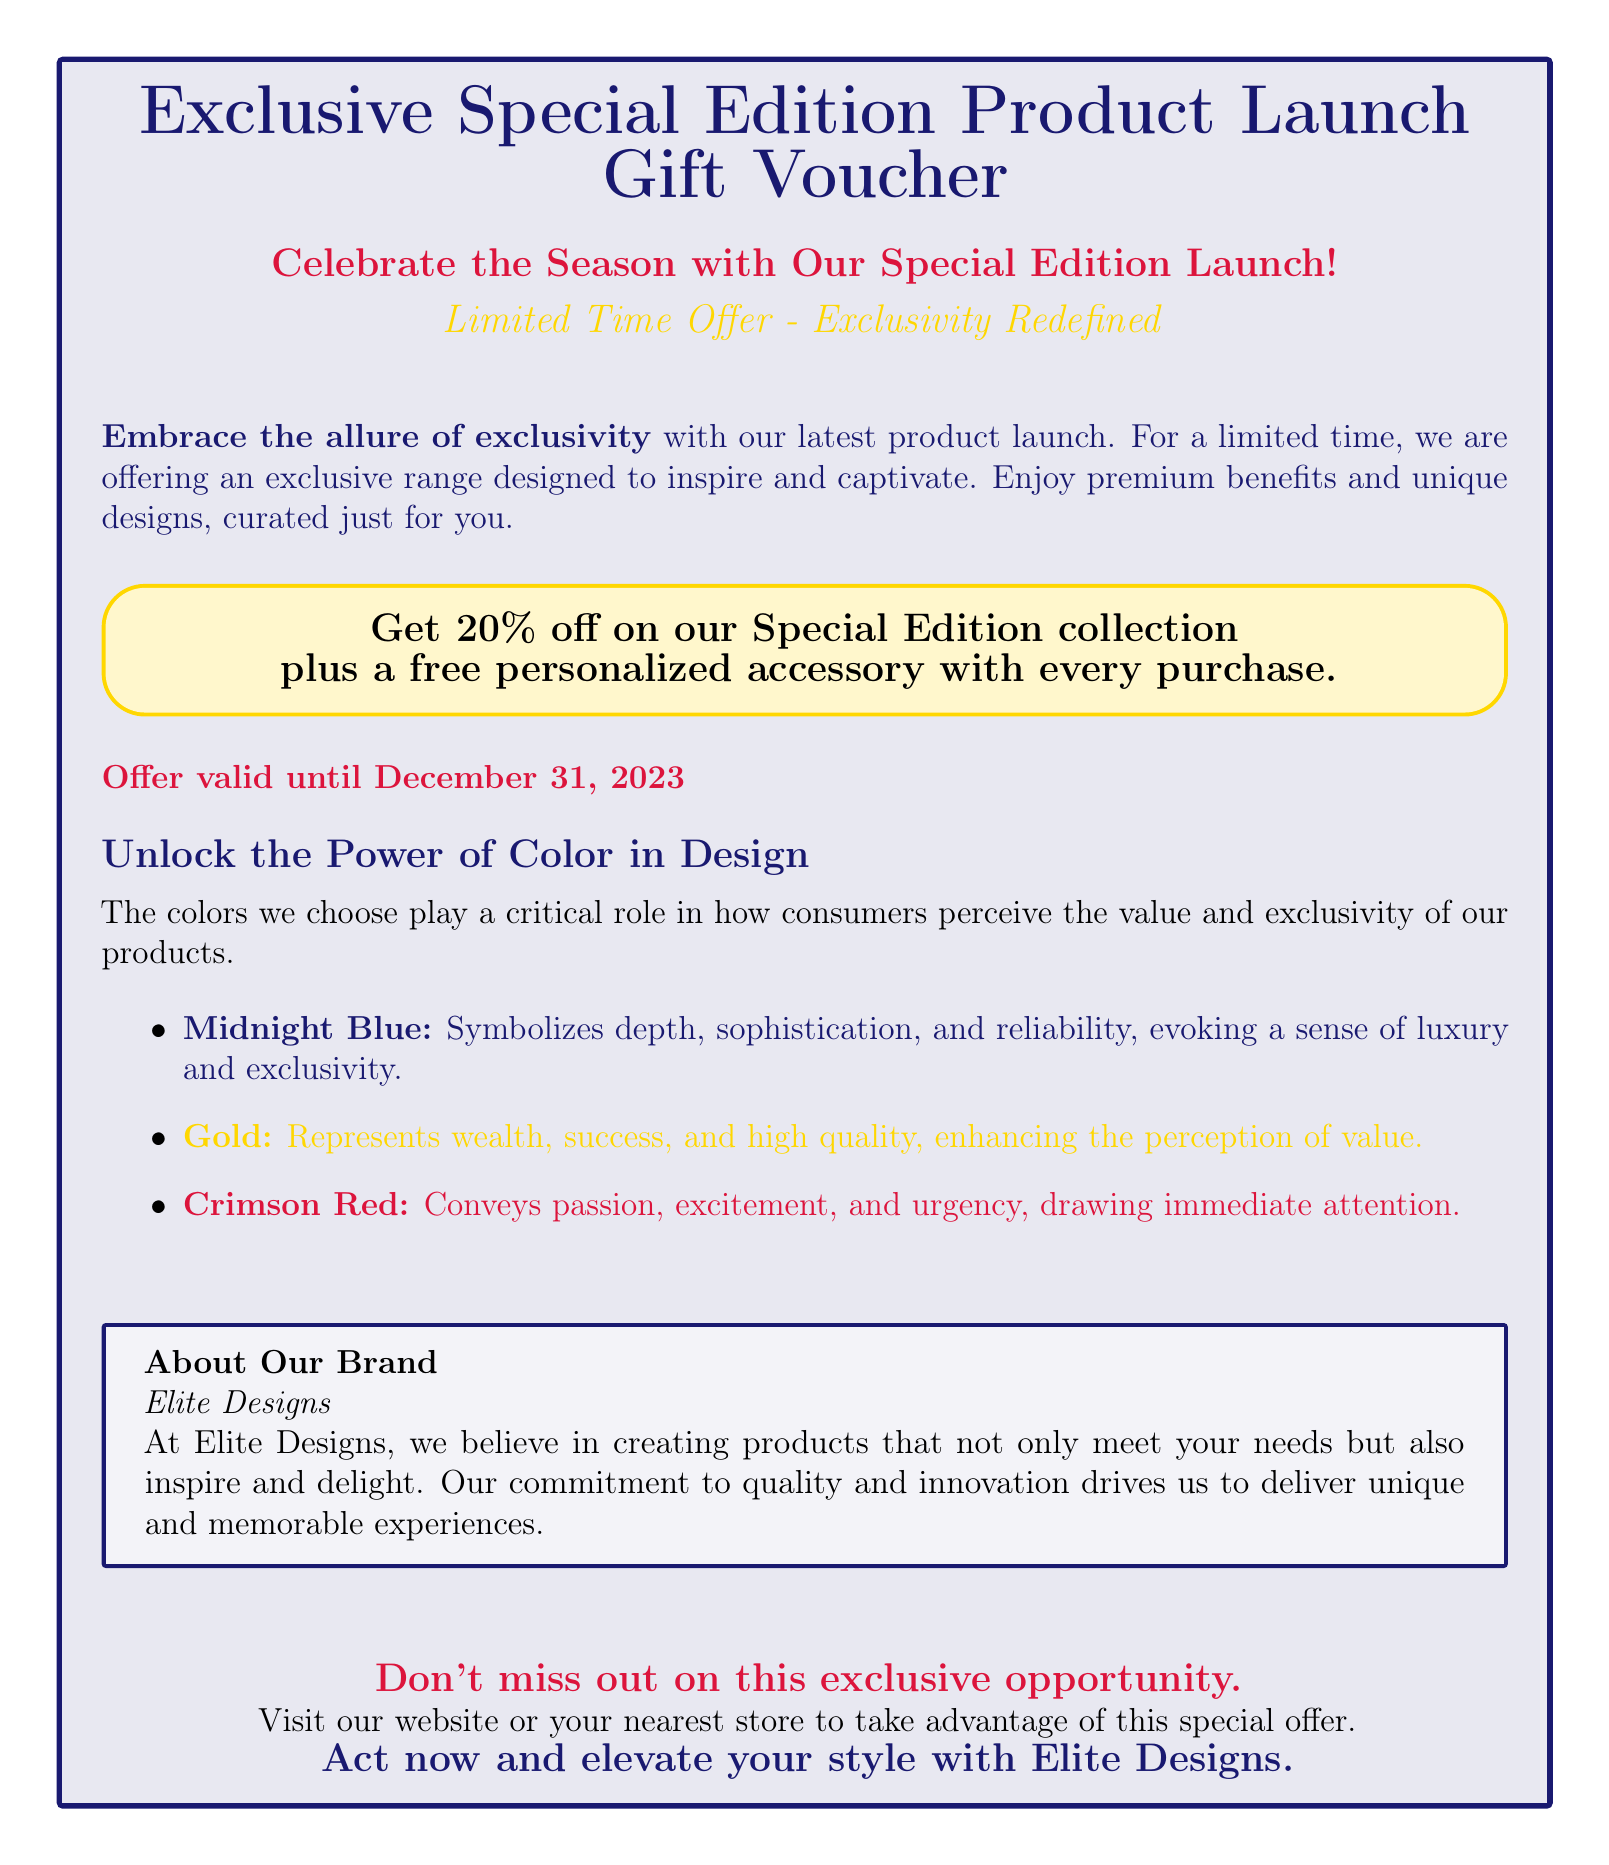What is the main purpose of this voucher? The main purpose of the voucher is to promote a special edition product launch with exclusive offers.
Answer: Exclusive Special Edition Product Launch Gift Voucher What is the discount offered on the special edition collection? The document states that customers can enjoy a discount of 20% on the special edition collection.
Answer: 20% What date is the offer valid until? The document specifies that the offer is valid until December 31, 2023.
Answer: December 31, 2023 Which color represents wealth and high quality? The document indicates that the color gold represents wealth and high quality.
Answer: Gold What brand is promoting this special edition product launch? The voucher indicates that the brand promoting the launch is Elite Designs.
Answer: Elite Designs What type of accessory is offered for free with every purchase? The document mentions that a personalized accessory is offered for free with each purchase.
Answer: Personalized accessory What color symbolizes luxury and exclusivity according to the document? The document states that midnight blue symbolizes depth, sophistication, and luxury.
Answer: Midnight Blue How is crimson red described in terms of consumer perception? The document describes crimson red as conveying passion, excitement, and urgency.
Answer: Passion, excitement, and urgency What is the primary incentive for consumers to act quickly on this voucher? The document highlights that the offer is described as an exclusive opportunity, urging consumers not to miss out.
Answer: Exclusive opportunity 